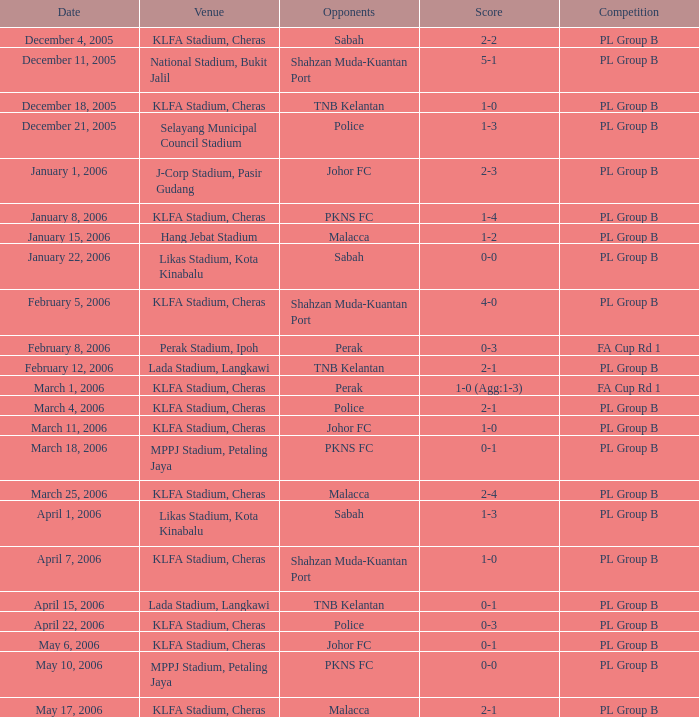Who participated in the competition on may 6, 2006? Johor FC. 